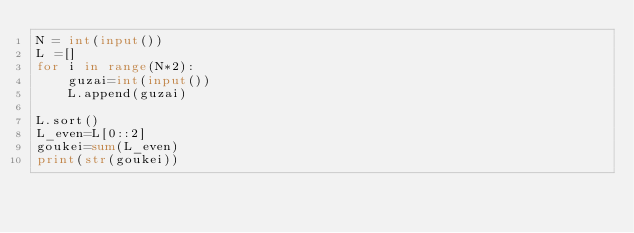Convert code to text. <code><loc_0><loc_0><loc_500><loc_500><_Python_>N = int(input())
L =[]
for i in range(N*2):
    guzai=int(input())
    L.append(guzai)

L.sort()
L_even=L[0::2]
goukei=sum(L_even)
print(str(goukei))</code> 